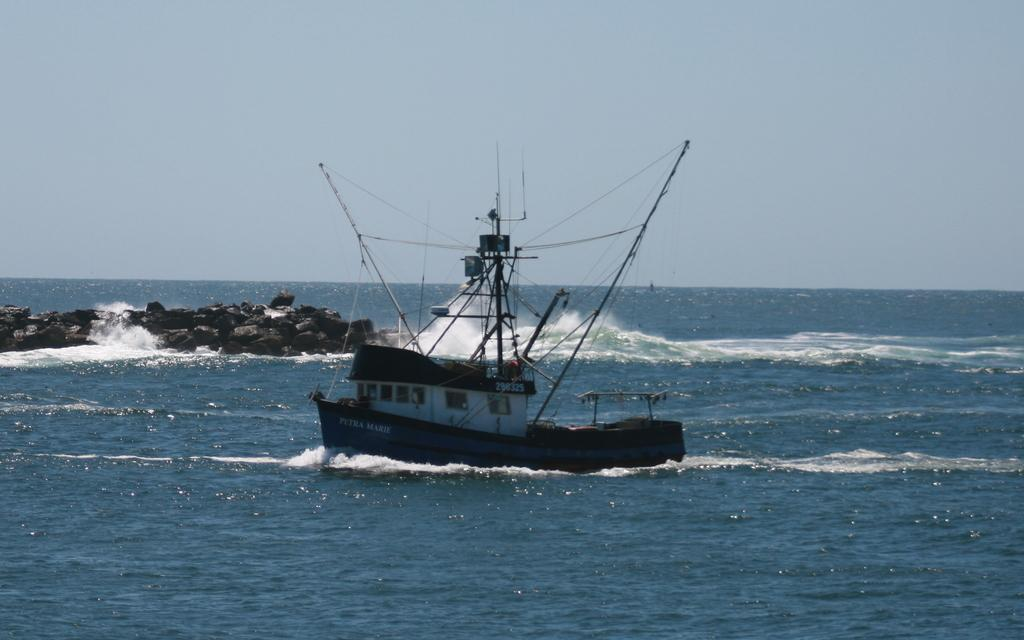What is the main subject of the image? The main subject of the image is a boat. Where is the boat located? The boat is on a sea. What else can be seen in the image besides the boat? There are rocks in the image. What is visible in the background of the image? The sky is visible in the background of the image. How many girls are sitting on the rocks in the image? There are no girls present in the image; it features a boat on a sea with rocks. 